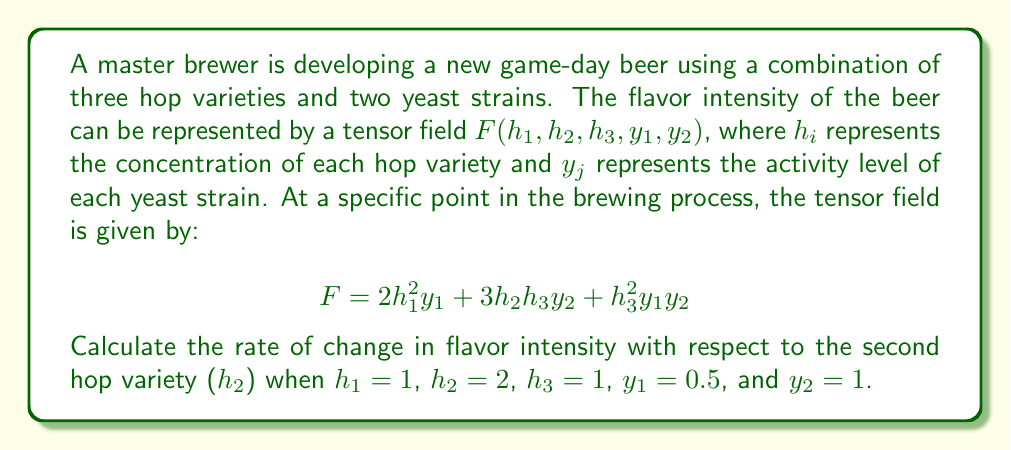Solve this math problem. To solve this problem, we need to follow these steps:

1) The rate of change in flavor intensity with respect to $h_2$ is given by the partial derivative $\frac{\partial F}{\partial h_2}$.

2) Let's calculate this partial derivative:

   $$\frac{\partial F}{\partial h_2} = \frac{\partial}{\partial h_2}(2h_1^2y_1 + 3h_2h_3y_2 + h_3^2y_1y_2)$$
   
   $$\frac{\partial F}{\partial h_2} = 3h_3y_2$$

3) Now, we need to substitute the given values:
   $h_3 = 1$ and $y_2 = 1$

4) Substituting these values into our partial derivative:

   $$\frac{\partial F}{\partial h_2} = 3 \cdot 1 \cdot 1 = 3$$

Therefore, at the given point in the brewing process, the rate of change in flavor intensity with respect to the second hop variety is 3 units of flavor intensity per unit change in $h_2$.
Answer: $3$ 